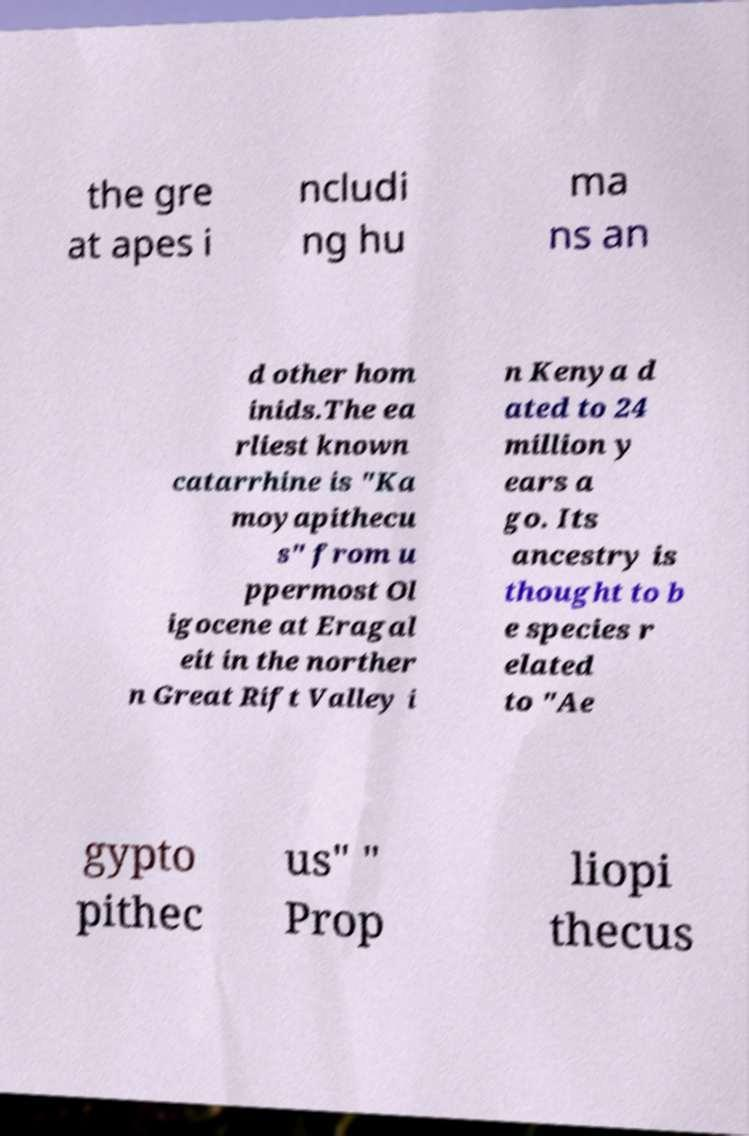For documentation purposes, I need the text within this image transcribed. Could you provide that? the gre at apes i ncludi ng hu ma ns an d other hom inids.The ea rliest known catarrhine is "Ka moyapithecu s" from u ppermost Ol igocene at Eragal eit in the norther n Great Rift Valley i n Kenya d ated to 24 million y ears a go. Its ancestry is thought to b e species r elated to "Ae gypto pithec us" " Prop liopi thecus 